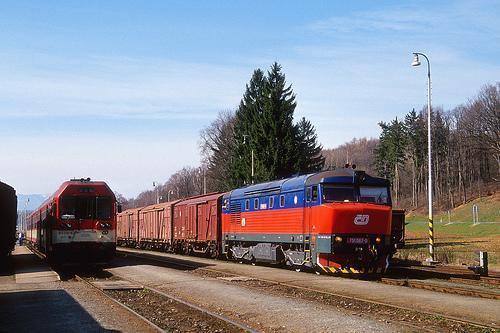How many trains are there?
Give a very brief answer. 2. How many trains?
Give a very brief answer. 2. How many trains are pictured?
Give a very brief answer. 2. How many trains are on the tracks?
Give a very brief answer. 2. 